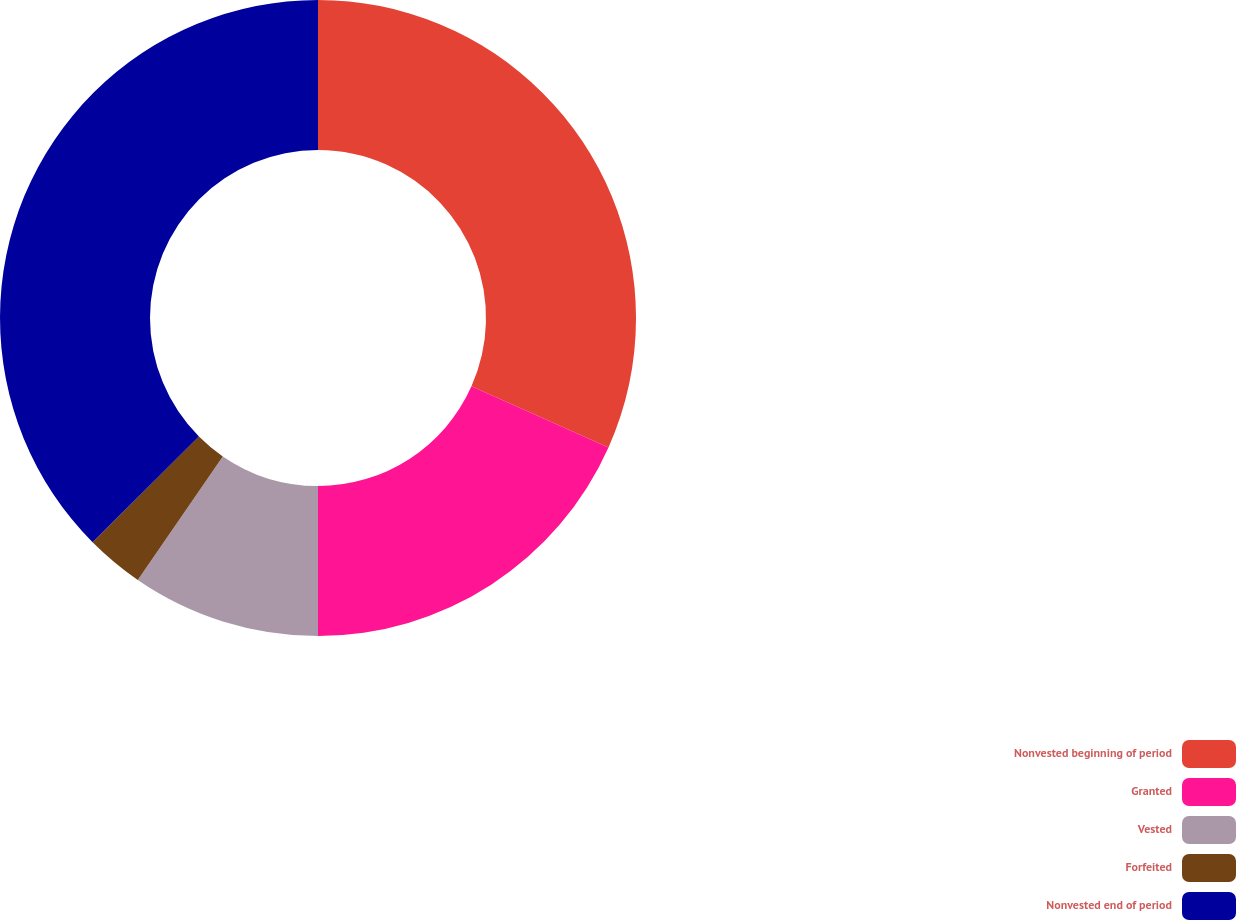<chart> <loc_0><loc_0><loc_500><loc_500><pie_chart><fcel>Nonvested beginning of period<fcel>Granted<fcel>Vested<fcel>Forfeited<fcel>Nonvested end of period<nl><fcel>31.67%<fcel>18.33%<fcel>9.59%<fcel>2.95%<fcel>37.46%<nl></chart> 